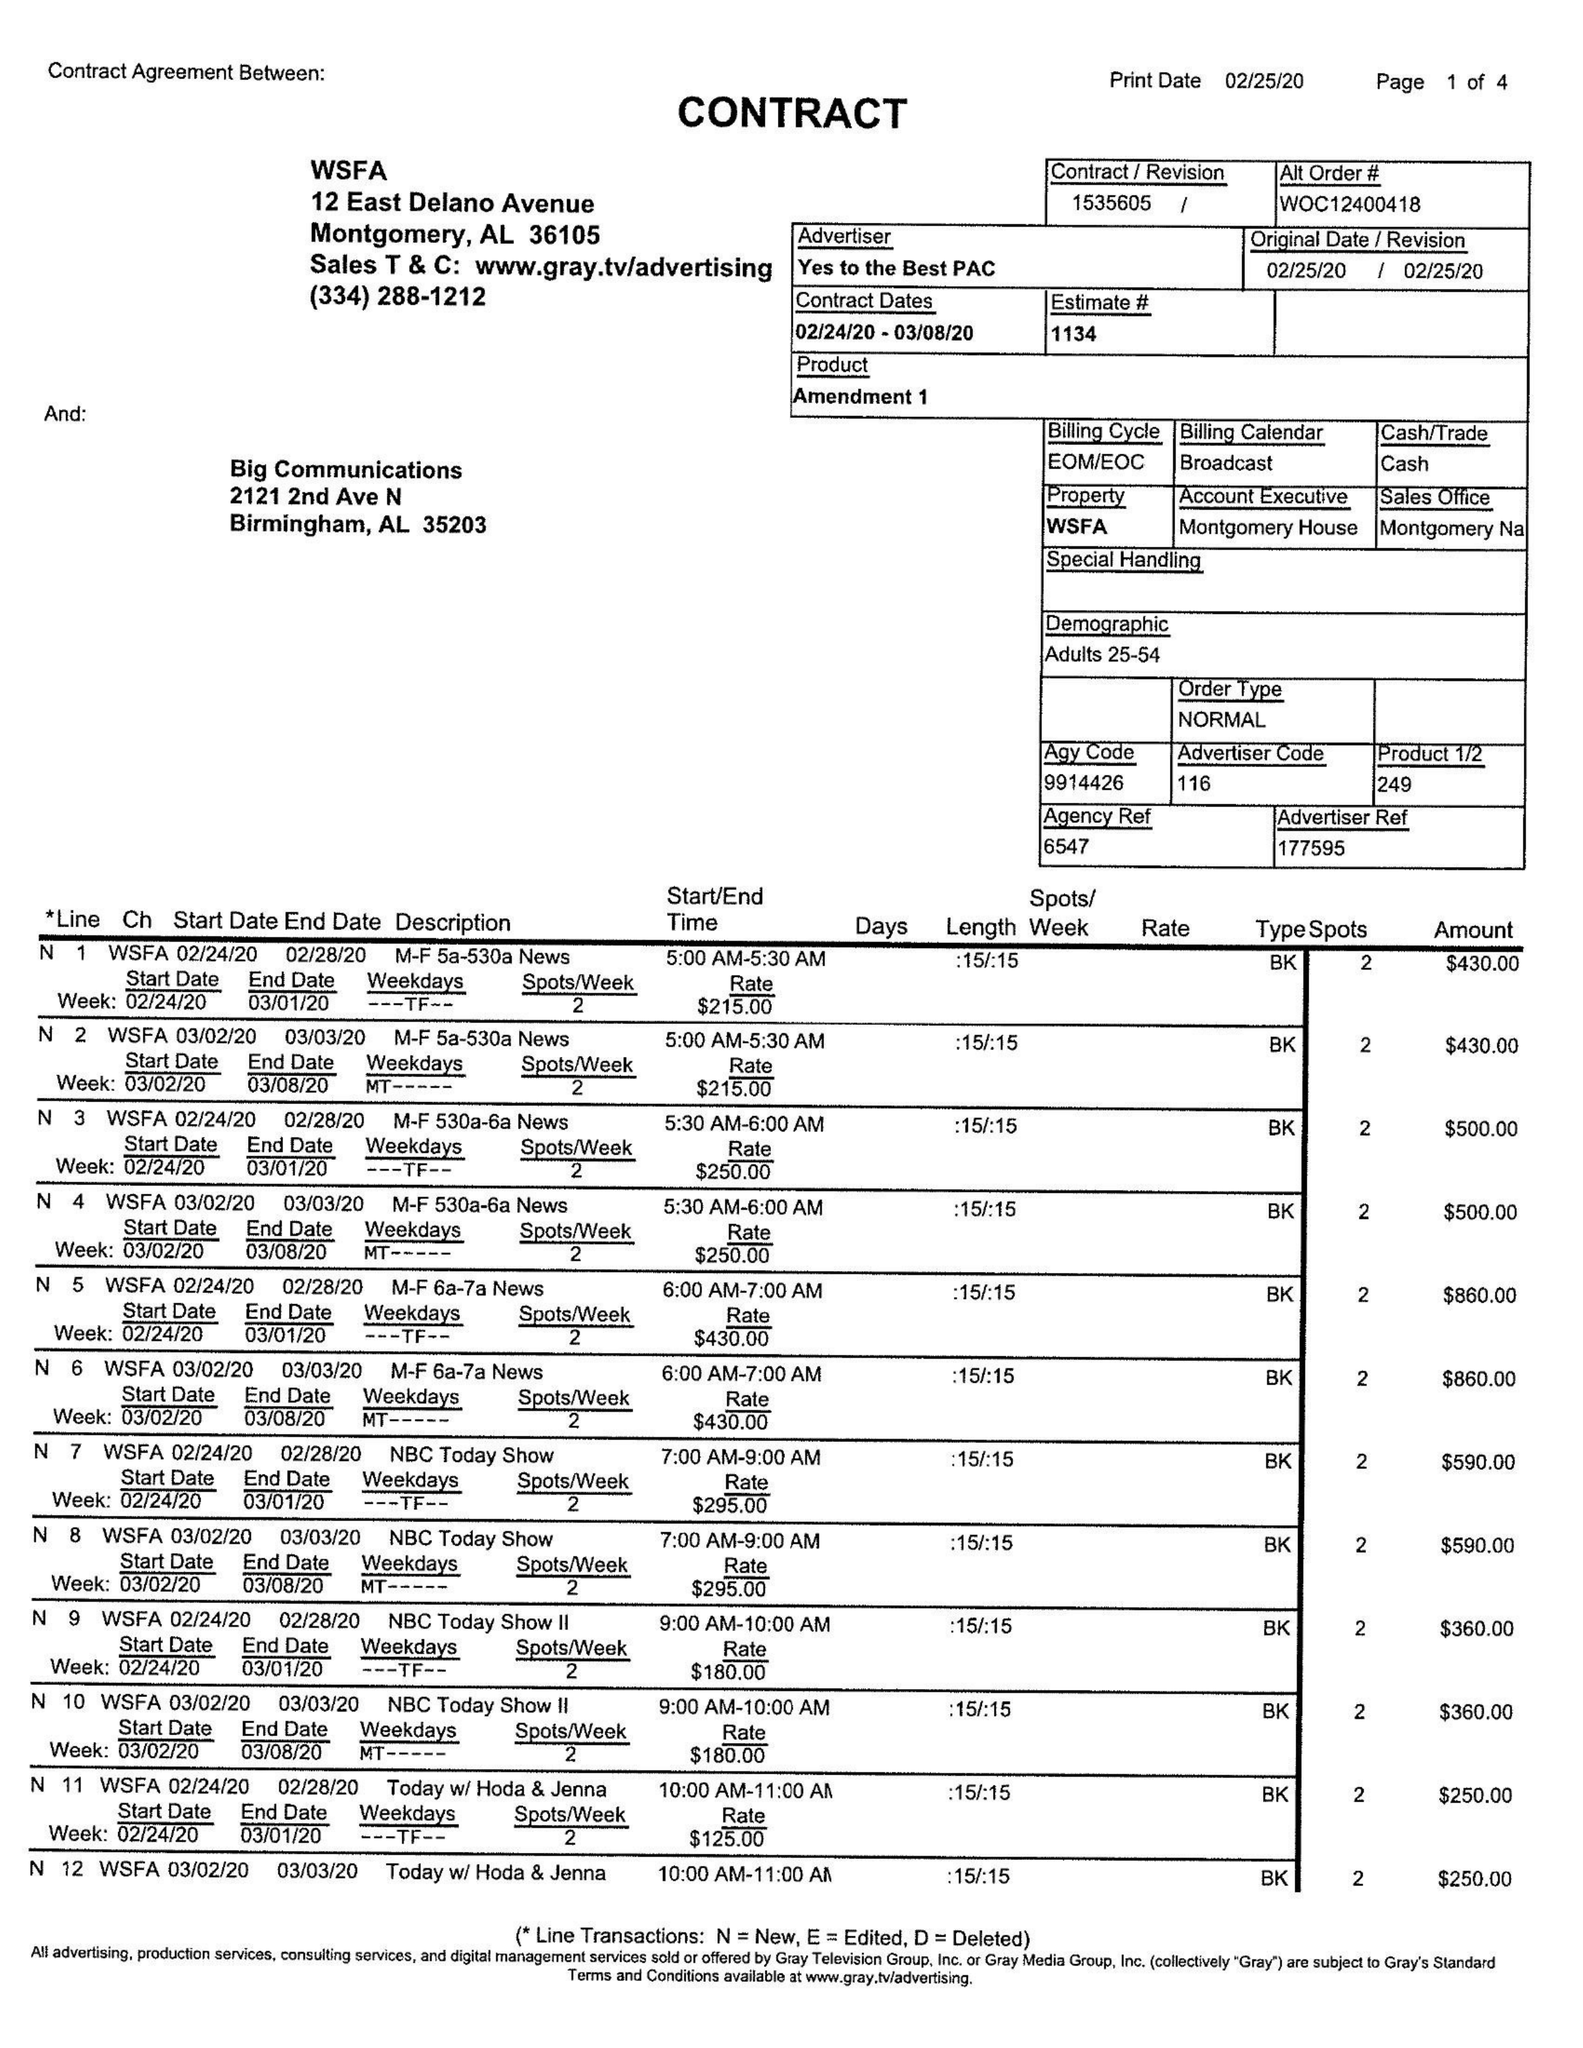What is the value for the contract_num?
Answer the question using a single word or phrase. 1535605 